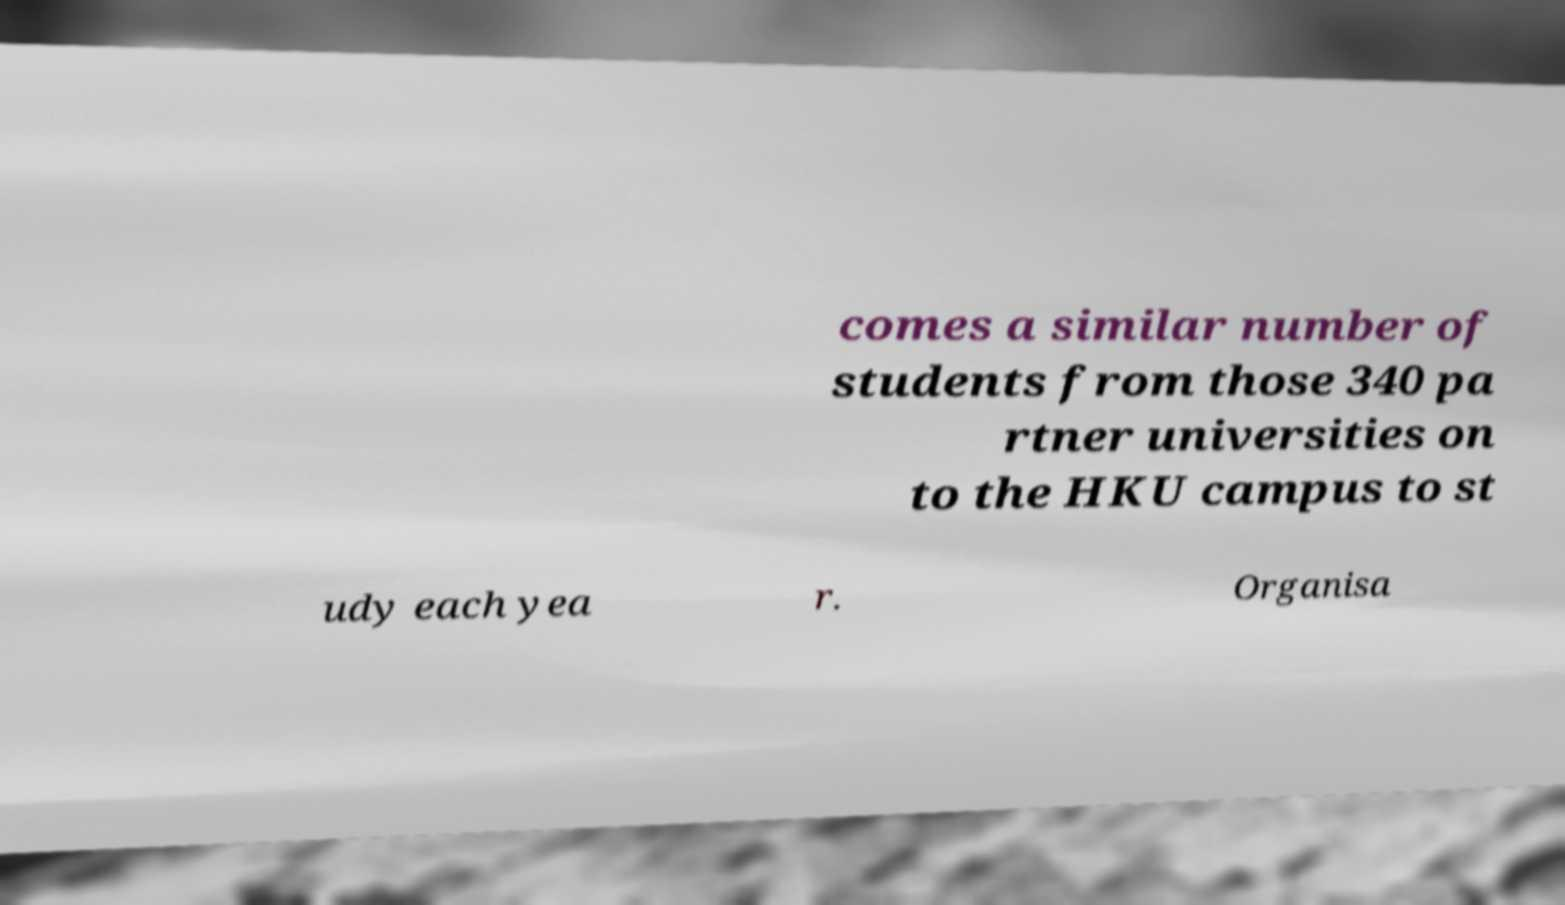What messages or text are displayed in this image? I need them in a readable, typed format. comes a similar number of students from those 340 pa rtner universities on to the HKU campus to st udy each yea r. Organisa 